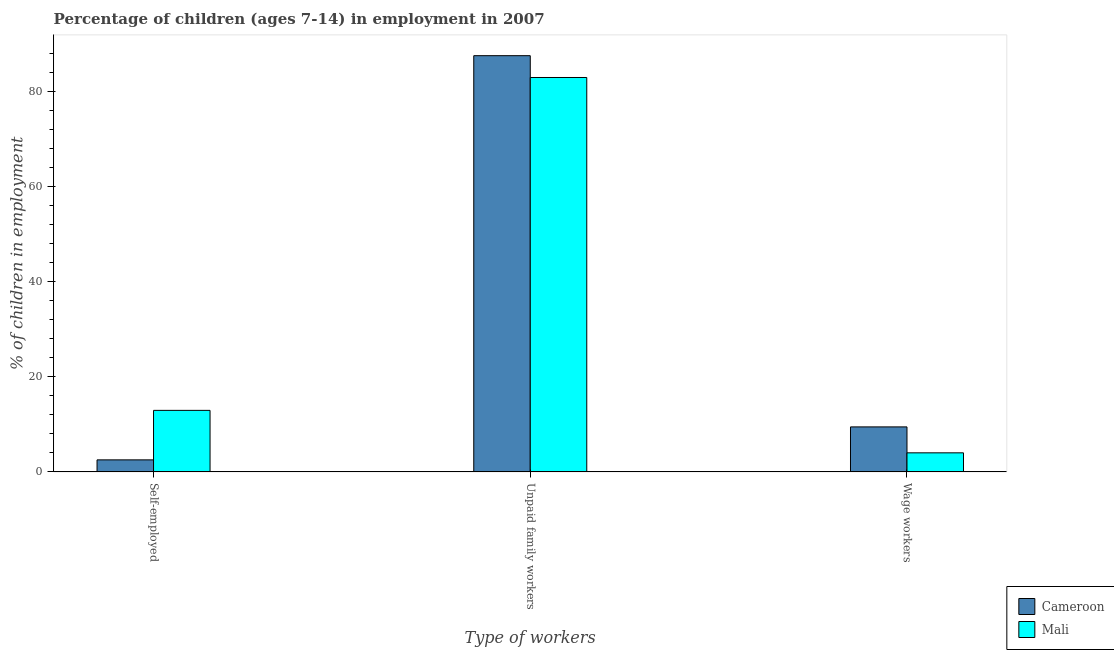How many different coloured bars are there?
Your response must be concise. 2. How many groups of bars are there?
Your answer should be very brief. 3. Are the number of bars per tick equal to the number of legend labels?
Provide a short and direct response. Yes. Are the number of bars on each tick of the X-axis equal?
Provide a short and direct response. Yes. How many bars are there on the 3rd tick from the left?
Provide a succinct answer. 2. How many bars are there on the 2nd tick from the right?
Ensure brevity in your answer.  2. What is the label of the 1st group of bars from the left?
Your answer should be compact. Self-employed. What is the percentage of children employed as unpaid family workers in Cameroon?
Offer a terse response. 87.61. Across all countries, what is the maximum percentage of self employed children?
Your response must be concise. 12.96. Across all countries, what is the minimum percentage of self employed children?
Make the answer very short. 2.54. In which country was the percentage of children employed as unpaid family workers maximum?
Your answer should be very brief. Cameroon. In which country was the percentage of children employed as unpaid family workers minimum?
Ensure brevity in your answer.  Mali. What is the total percentage of self employed children in the graph?
Make the answer very short. 15.5. What is the difference between the percentage of children employed as wage workers in Mali and that in Cameroon?
Your response must be concise. -5.46. What is the difference between the percentage of self employed children in Mali and the percentage of children employed as unpaid family workers in Cameroon?
Your answer should be compact. -74.65. What is the average percentage of children employed as wage workers per country?
Make the answer very short. 6.75. What is the difference between the percentage of children employed as wage workers and percentage of children employed as unpaid family workers in Cameroon?
Provide a succinct answer. -78.13. What is the ratio of the percentage of children employed as unpaid family workers in Cameroon to that in Mali?
Keep it short and to the point. 1.06. Is the percentage of self employed children in Cameroon less than that in Mali?
Your answer should be compact. Yes. What is the difference between the highest and the second highest percentage of children employed as unpaid family workers?
Offer a very short reply. 4.59. What is the difference between the highest and the lowest percentage of children employed as wage workers?
Offer a very short reply. 5.46. What does the 2nd bar from the left in Self-employed represents?
Your answer should be compact. Mali. What does the 1st bar from the right in Unpaid family workers represents?
Ensure brevity in your answer.  Mali. How many bars are there?
Offer a very short reply. 6. Are all the bars in the graph horizontal?
Offer a very short reply. No. How many countries are there in the graph?
Ensure brevity in your answer.  2. What is the difference between two consecutive major ticks on the Y-axis?
Keep it short and to the point. 20. Are the values on the major ticks of Y-axis written in scientific E-notation?
Provide a succinct answer. No. Does the graph contain any zero values?
Keep it short and to the point. No. How many legend labels are there?
Keep it short and to the point. 2. What is the title of the graph?
Provide a short and direct response. Percentage of children (ages 7-14) in employment in 2007. What is the label or title of the X-axis?
Your answer should be very brief. Type of workers. What is the label or title of the Y-axis?
Your answer should be very brief. % of children in employment. What is the % of children in employment of Cameroon in Self-employed?
Offer a very short reply. 2.54. What is the % of children in employment of Mali in Self-employed?
Give a very brief answer. 12.96. What is the % of children in employment of Cameroon in Unpaid family workers?
Your answer should be compact. 87.61. What is the % of children in employment of Mali in Unpaid family workers?
Offer a very short reply. 83.02. What is the % of children in employment of Cameroon in Wage workers?
Your answer should be very brief. 9.48. What is the % of children in employment in Mali in Wage workers?
Your answer should be compact. 4.02. Across all Type of workers, what is the maximum % of children in employment in Cameroon?
Provide a succinct answer. 87.61. Across all Type of workers, what is the maximum % of children in employment of Mali?
Your answer should be very brief. 83.02. Across all Type of workers, what is the minimum % of children in employment in Cameroon?
Your response must be concise. 2.54. Across all Type of workers, what is the minimum % of children in employment of Mali?
Provide a succinct answer. 4.02. What is the total % of children in employment in Cameroon in the graph?
Your response must be concise. 99.63. What is the difference between the % of children in employment in Cameroon in Self-employed and that in Unpaid family workers?
Provide a short and direct response. -85.07. What is the difference between the % of children in employment in Mali in Self-employed and that in Unpaid family workers?
Your answer should be very brief. -70.06. What is the difference between the % of children in employment in Cameroon in Self-employed and that in Wage workers?
Ensure brevity in your answer.  -6.94. What is the difference between the % of children in employment in Mali in Self-employed and that in Wage workers?
Ensure brevity in your answer.  8.94. What is the difference between the % of children in employment in Cameroon in Unpaid family workers and that in Wage workers?
Your answer should be compact. 78.13. What is the difference between the % of children in employment of Mali in Unpaid family workers and that in Wage workers?
Offer a very short reply. 79. What is the difference between the % of children in employment of Cameroon in Self-employed and the % of children in employment of Mali in Unpaid family workers?
Your response must be concise. -80.48. What is the difference between the % of children in employment of Cameroon in Self-employed and the % of children in employment of Mali in Wage workers?
Offer a terse response. -1.48. What is the difference between the % of children in employment in Cameroon in Unpaid family workers and the % of children in employment in Mali in Wage workers?
Give a very brief answer. 83.59. What is the average % of children in employment in Cameroon per Type of workers?
Your response must be concise. 33.21. What is the average % of children in employment in Mali per Type of workers?
Make the answer very short. 33.33. What is the difference between the % of children in employment in Cameroon and % of children in employment in Mali in Self-employed?
Provide a short and direct response. -10.42. What is the difference between the % of children in employment in Cameroon and % of children in employment in Mali in Unpaid family workers?
Ensure brevity in your answer.  4.59. What is the difference between the % of children in employment in Cameroon and % of children in employment in Mali in Wage workers?
Offer a very short reply. 5.46. What is the ratio of the % of children in employment of Cameroon in Self-employed to that in Unpaid family workers?
Ensure brevity in your answer.  0.03. What is the ratio of the % of children in employment in Mali in Self-employed to that in Unpaid family workers?
Offer a terse response. 0.16. What is the ratio of the % of children in employment in Cameroon in Self-employed to that in Wage workers?
Your answer should be compact. 0.27. What is the ratio of the % of children in employment in Mali in Self-employed to that in Wage workers?
Your answer should be compact. 3.22. What is the ratio of the % of children in employment of Cameroon in Unpaid family workers to that in Wage workers?
Provide a short and direct response. 9.24. What is the ratio of the % of children in employment in Mali in Unpaid family workers to that in Wage workers?
Your answer should be compact. 20.65. What is the difference between the highest and the second highest % of children in employment in Cameroon?
Give a very brief answer. 78.13. What is the difference between the highest and the second highest % of children in employment of Mali?
Your answer should be very brief. 70.06. What is the difference between the highest and the lowest % of children in employment of Cameroon?
Provide a succinct answer. 85.07. What is the difference between the highest and the lowest % of children in employment of Mali?
Offer a terse response. 79. 